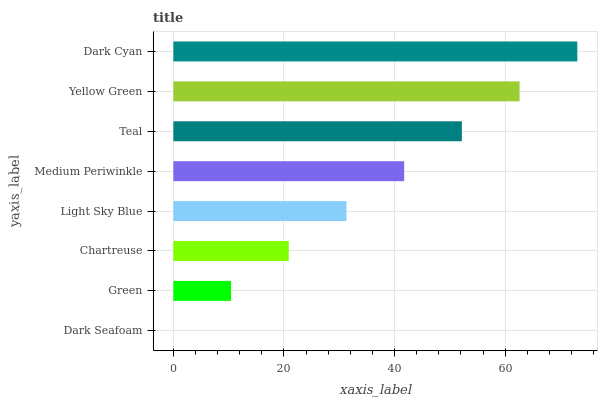Is Dark Seafoam the minimum?
Answer yes or no. Yes. Is Dark Cyan the maximum?
Answer yes or no. Yes. Is Green the minimum?
Answer yes or no. No. Is Green the maximum?
Answer yes or no. No. Is Green greater than Dark Seafoam?
Answer yes or no. Yes. Is Dark Seafoam less than Green?
Answer yes or no. Yes. Is Dark Seafoam greater than Green?
Answer yes or no. No. Is Green less than Dark Seafoam?
Answer yes or no. No. Is Medium Periwinkle the high median?
Answer yes or no. Yes. Is Light Sky Blue the low median?
Answer yes or no. Yes. Is Teal the high median?
Answer yes or no. No. Is Dark Cyan the low median?
Answer yes or no. No. 